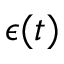Convert formula to latex. <formula><loc_0><loc_0><loc_500><loc_500>\epsilon ( t )</formula> 